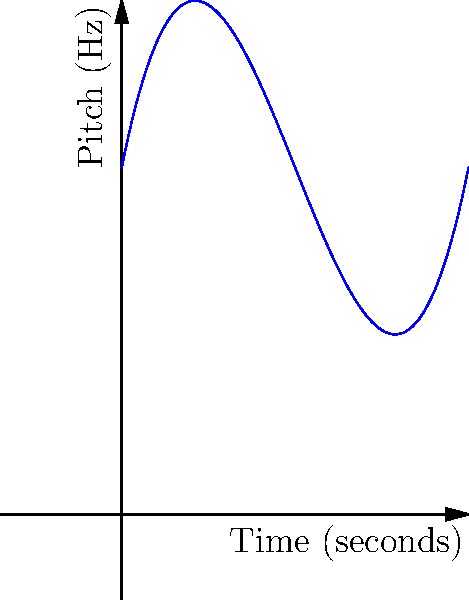In one of Itziar Castro's musical performances, the pitch progression of her voice can be modeled by the polynomial function $f(x) = 0.1x^3 - 1.5x^2 + 5x + 10$, where $x$ represents time in seconds and $f(x)$ represents pitch in Hz. At which point (A, B, or C) does Itziar's voice reach its lowest pitch during this 10-second segment of the song? To find the lowest pitch in Itziar Castro's performance, we need to determine the minimum point of the given polynomial function within the interval [0, 10].

Step 1: Find the derivative of the function.
$f'(x) = 0.3x^2 - 3x + 5$

Step 2: Set the derivative to zero and solve for x.
$0.3x^2 - 3x + 5 = 0$
This is a quadratic equation. We can solve it using the quadratic formula:
$x = \frac{-b \pm \sqrt{b^2 - 4ac}}{2a}$

Where $a = 0.3$, $b = -3$, and $c = 5$

$x = \frac{3 \pm \sqrt{9 - 6}}{0.6} = \frac{3 \pm \sqrt{3}}{0.6}$

Step 3: Calculate the two critical points:
$x_1 = \frac{3 + \sqrt{3}}{0.6} \approx 6.88$ seconds
$x_2 = \frac{3 - \sqrt{3}}{0.6} \approx 3.12$ seconds

Step 4: Since $x_2$ is within our interval [0, 10] and $x_1$ is not, the minimum point occurs at $x_2 \approx 3.12$ seconds.

Step 5: Comparing this to the given points:
Point A: x ≈ 0.5 seconds
Point B: x = 5 seconds
Point C: x ≈ 9.5 seconds

The point closest to our calculated minimum (3.12 seconds) is Point B at 5 seconds.

Therefore, Itziar's voice reaches its lowest pitch closest to Point B on the graph.
Answer: B 